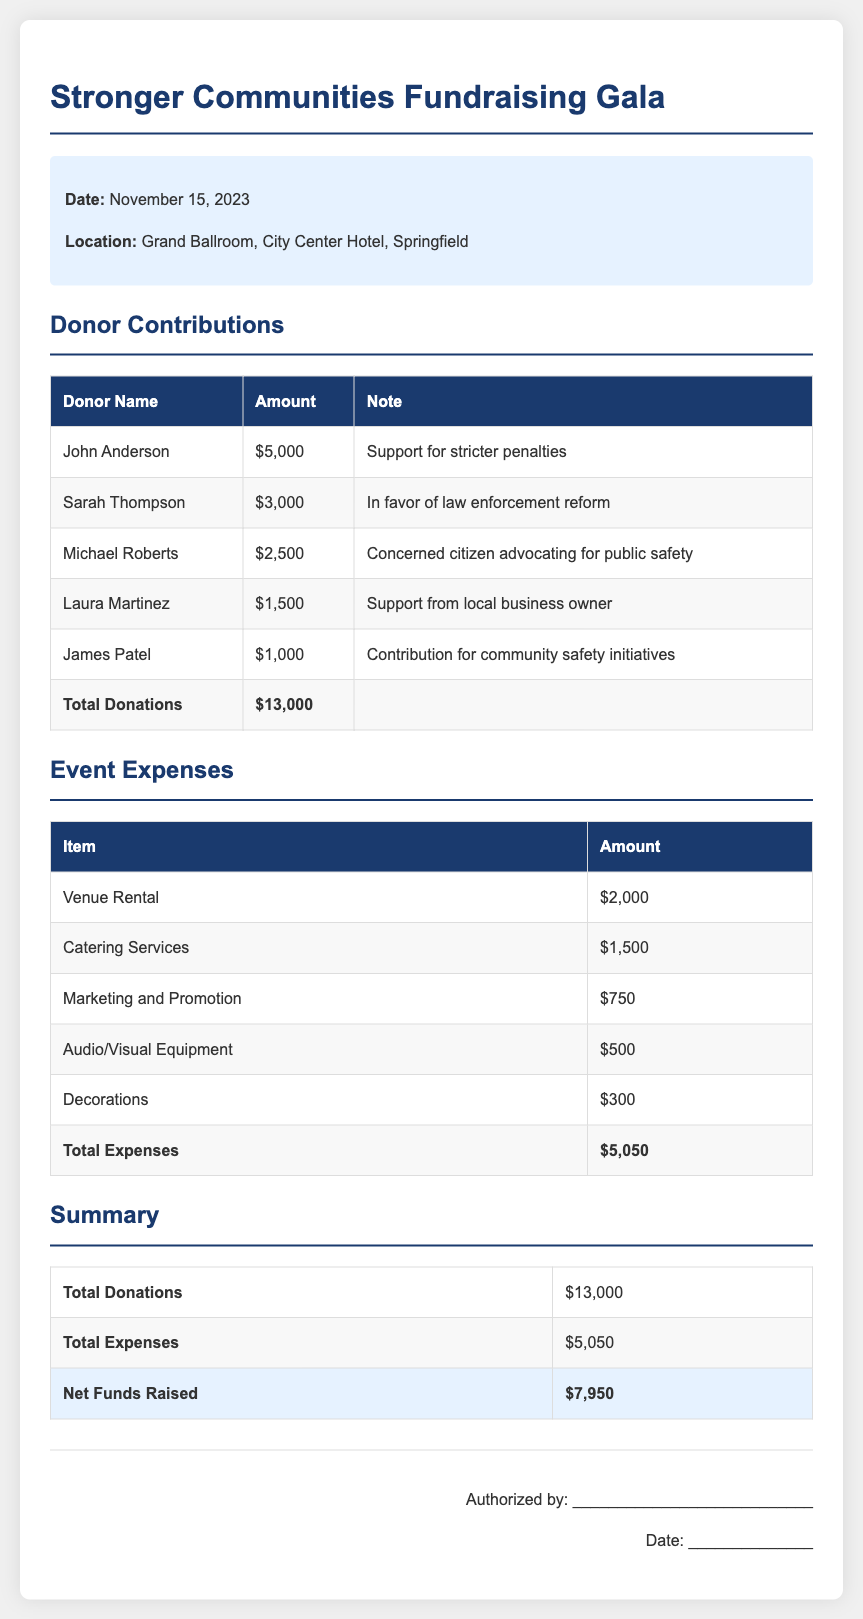What is the date of the event? The date of the event is specifically mentioned in the document under event details.
Answer: November 15, 2023 Who contributed the highest amount? The document lists donor contributions in descending order, identifying the highest contributor.
Answer: John Anderson What is the total amount of donations? The total donations are summed up in the donor contributions section of the document.
Answer: $13,000 What is the sum of the event expenses? The total expenses are provided in the event expenses section.
Answer: $5,050 What is the net funds raised from this event? The net funds raised is calculated by subtracting the total expenses from the total donations in the summary section.
Answer: $7,950 Which item had the lowest expense? The expenses are listed in a table format, allowing easy identification of the item with the lowest cost.
Answer: Decorations What organization held the fundraising gala? The title at the top of the document indicates the name of the organization responsible for the gala.
Answer: Stronger Communities What type of event is described in the document? The title of the document reveals the nature of the event being discussed.
Answer: Fundraising Gala How many donors contributed more than $2,000? By reviewing the donor contributions table, the number of donors exceeding $2,000 can be counted.
Answer: 2 